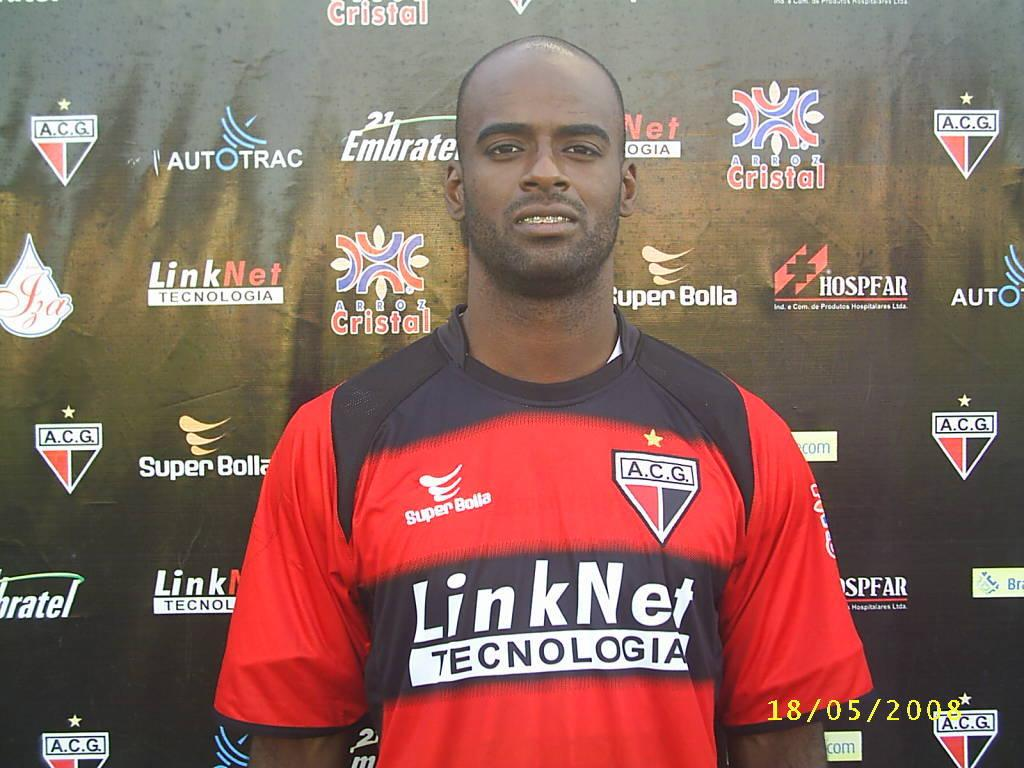<image>
Provide a brief description of the given image. A black fellow in a red shirt that says LinkNet Technologia. 